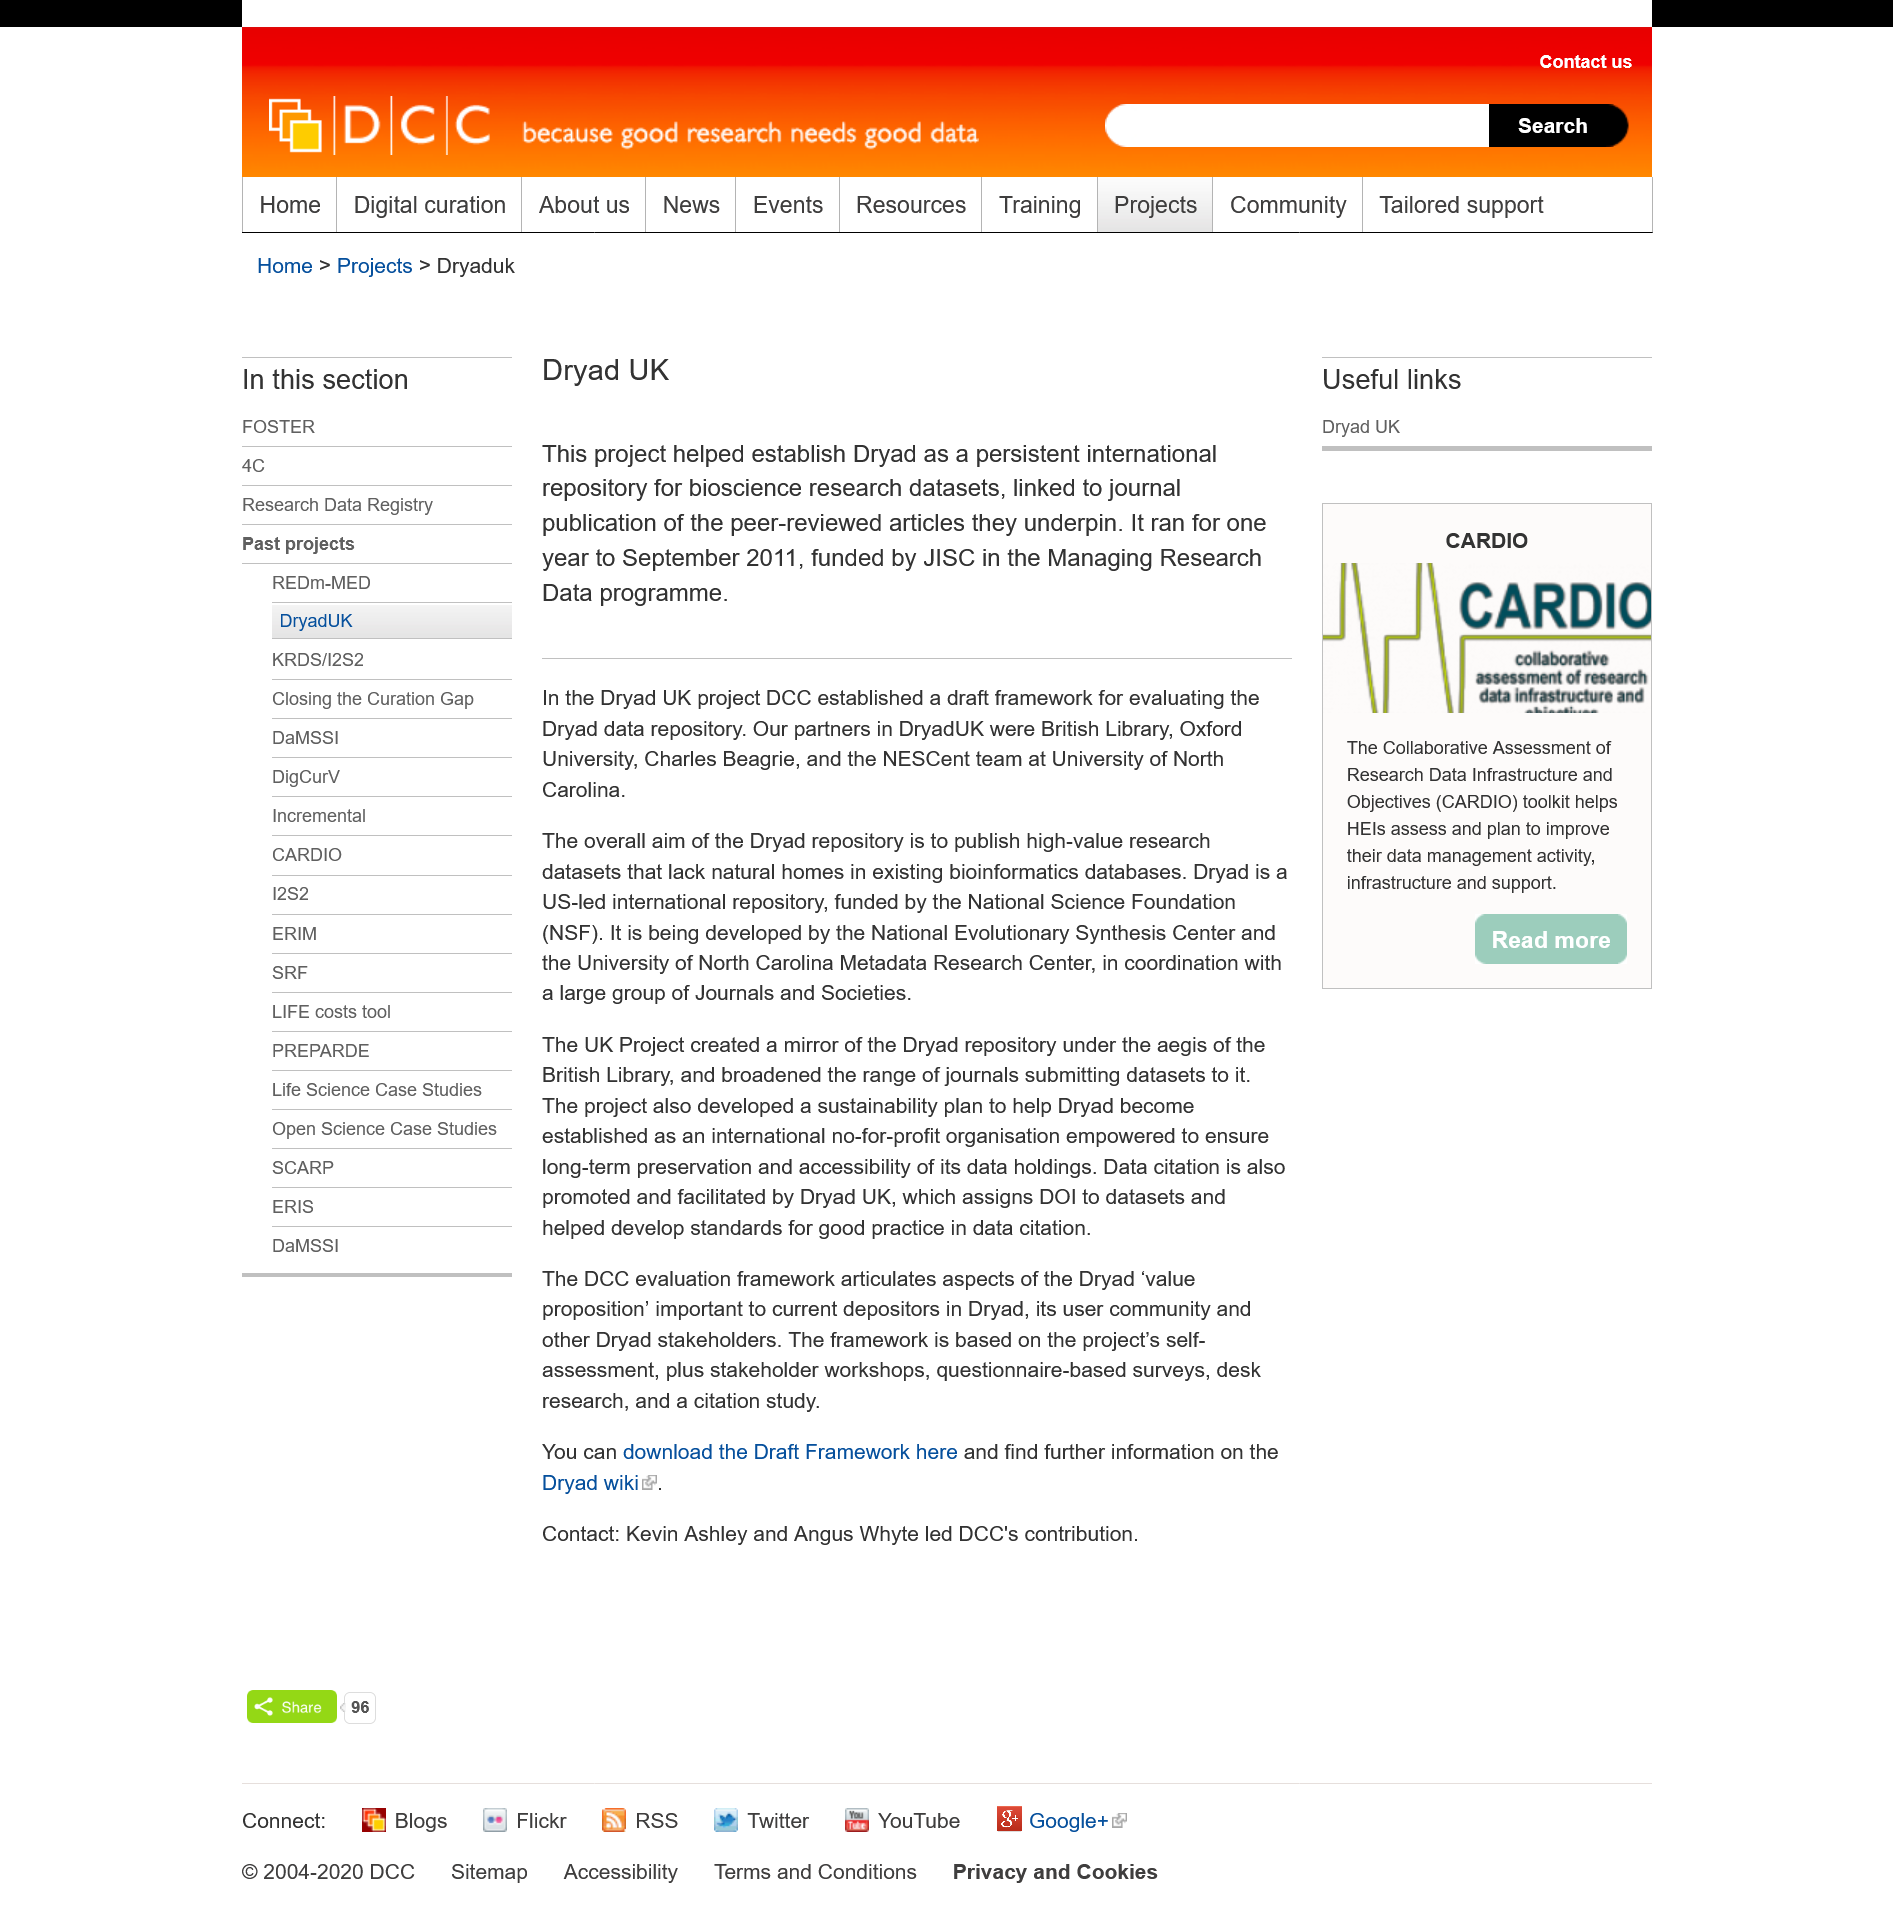Outline some significant characteristics in this image. Dryad UK operated for a period of one year. Dryad UK was funded by JISC. Dryad UK officially closed down in September 2011. 